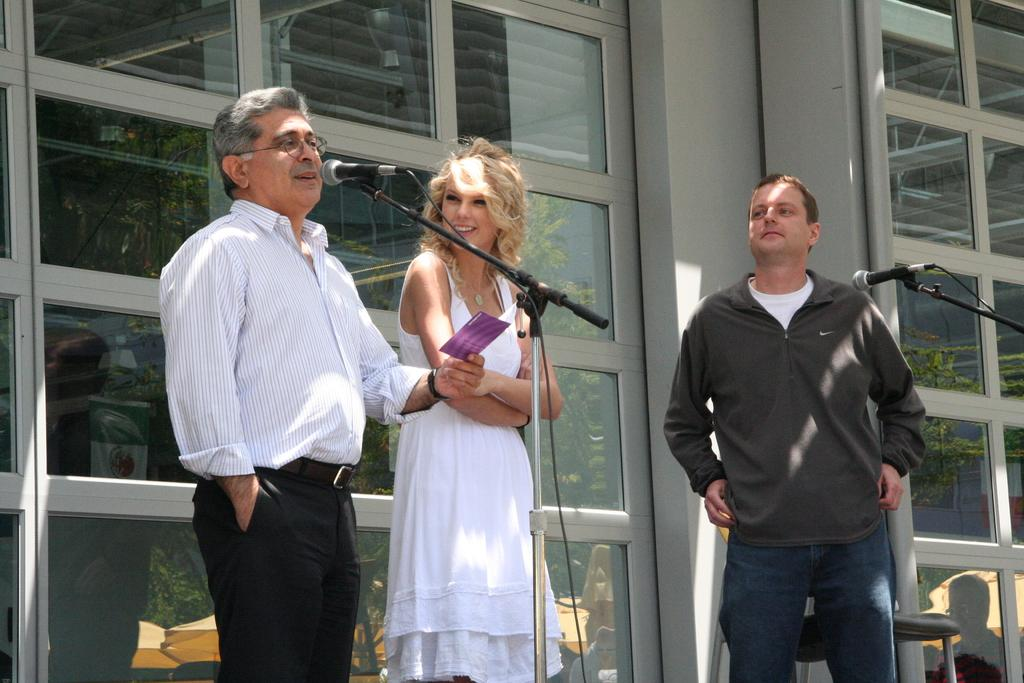How many people are in the image? There are two men and a woman in the image. What is one of the men doing in the image? One man is talking on a mic. What is the man holding while talking on the mic? The man is holding a paper in his hand. What can be seen in the background of the image? There is a chair, trees, and umbrellas in the background of the image. What type of process is being carried out by the fireman in the image? There is no fireman present in the image, so no such process can be observed. 